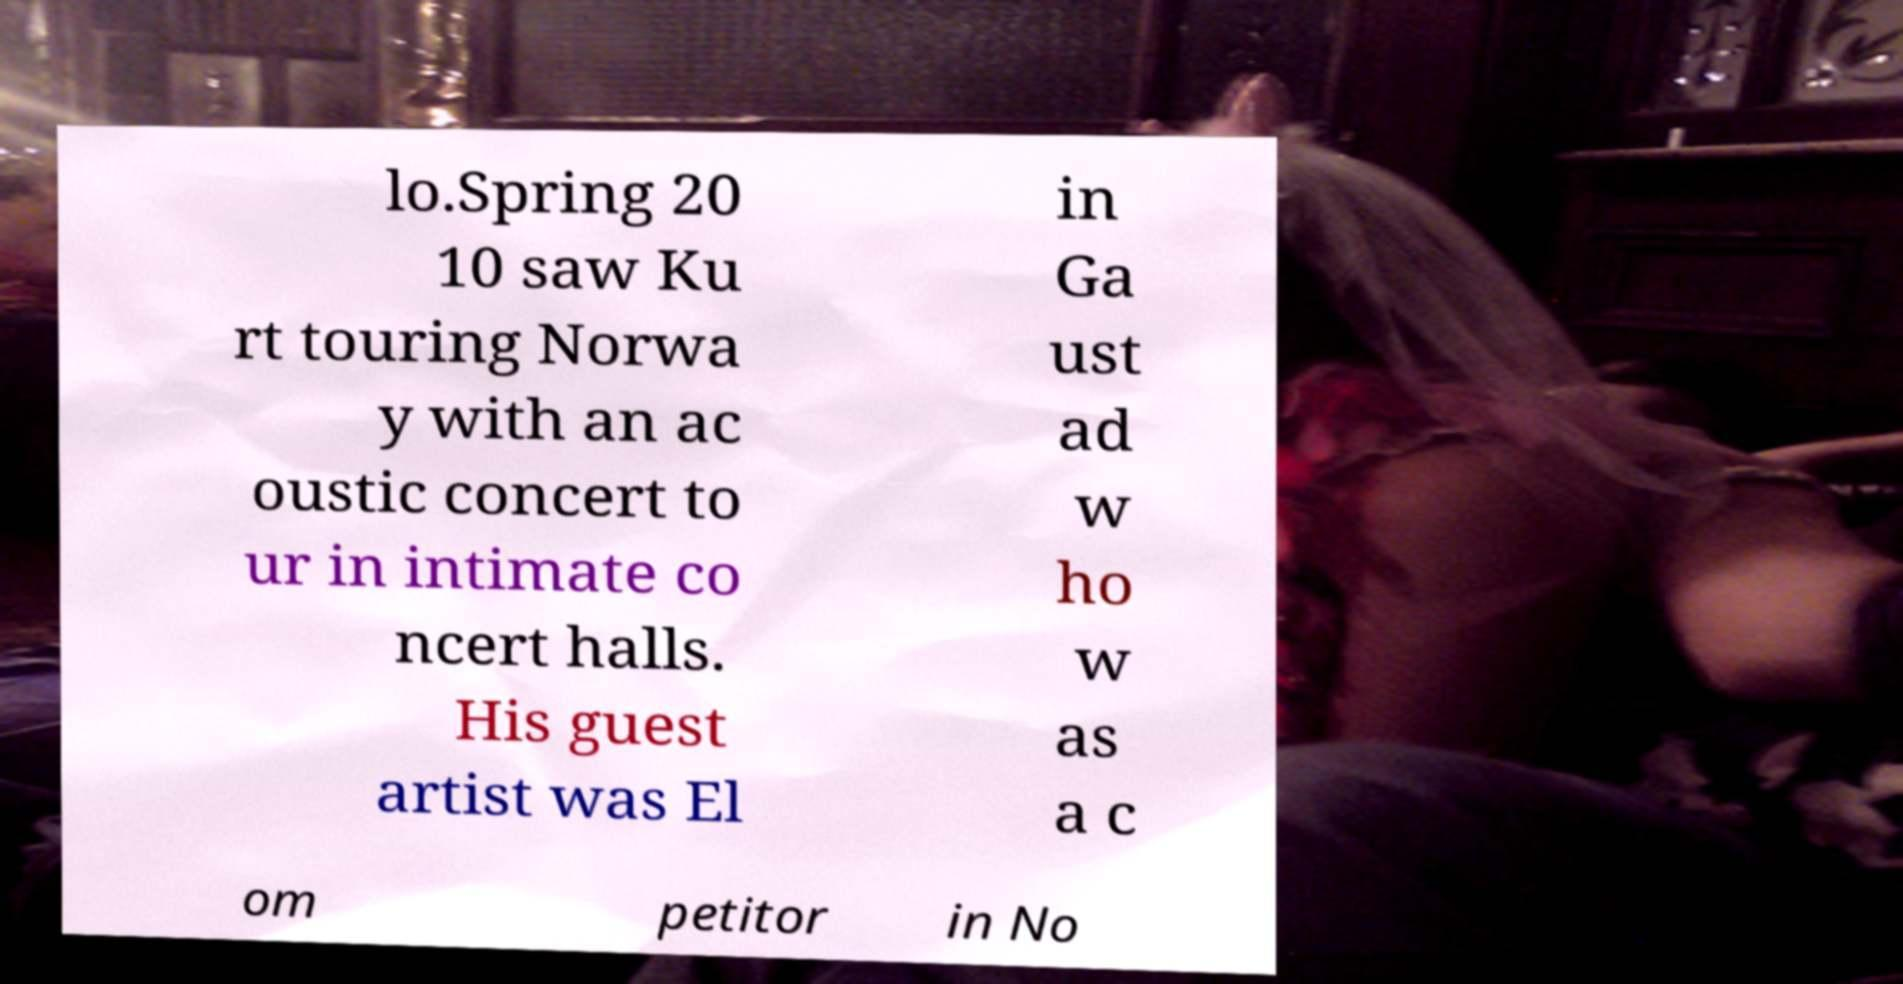There's text embedded in this image that I need extracted. Can you transcribe it verbatim? lo.Spring 20 10 saw Ku rt touring Norwa y with an ac oustic concert to ur in intimate co ncert halls. His guest artist was El in Ga ust ad w ho w as a c om petitor in No 